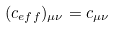<formula> <loc_0><loc_0><loc_500><loc_500>( { c _ { e f f } } ) _ { \mu \nu } = c _ { \mu \nu }</formula> 